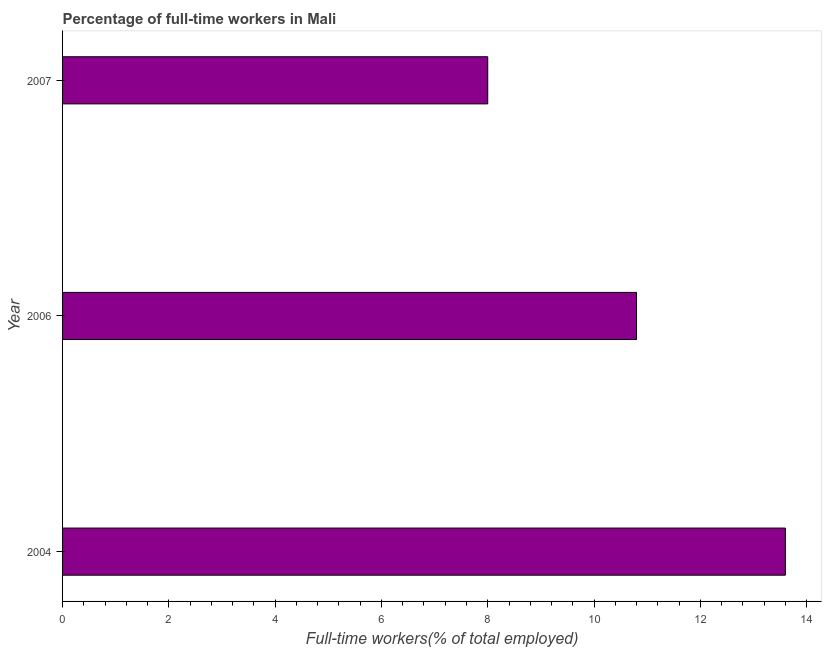What is the title of the graph?
Ensure brevity in your answer.  Percentage of full-time workers in Mali. What is the label or title of the X-axis?
Keep it short and to the point. Full-time workers(% of total employed). What is the label or title of the Y-axis?
Offer a very short reply. Year. Across all years, what is the maximum percentage of full-time workers?
Offer a terse response. 13.6. What is the sum of the percentage of full-time workers?
Make the answer very short. 32.4. What is the difference between the percentage of full-time workers in 2004 and 2006?
Offer a very short reply. 2.8. What is the median percentage of full-time workers?
Offer a terse response. 10.8. What is the ratio of the percentage of full-time workers in 2006 to that in 2007?
Your response must be concise. 1.35. What is the difference between the highest and the lowest percentage of full-time workers?
Provide a succinct answer. 5.6. Are all the bars in the graph horizontal?
Offer a terse response. Yes. How many years are there in the graph?
Your response must be concise. 3. Are the values on the major ticks of X-axis written in scientific E-notation?
Your answer should be compact. No. What is the Full-time workers(% of total employed) in 2004?
Give a very brief answer. 13.6. What is the Full-time workers(% of total employed) in 2006?
Ensure brevity in your answer.  10.8. What is the Full-time workers(% of total employed) in 2007?
Offer a terse response. 8. What is the difference between the Full-time workers(% of total employed) in 2004 and 2007?
Make the answer very short. 5.6. What is the ratio of the Full-time workers(% of total employed) in 2004 to that in 2006?
Give a very brief answer. 1.26. What is the ratio of the Full-time workers(% of total employed) in 2006 to that in 2007?
Keep it short and to the point. 1.35. 